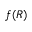<formula> <loc_0><loc_0><loc_500><loc_500>f ( R )</formula> 